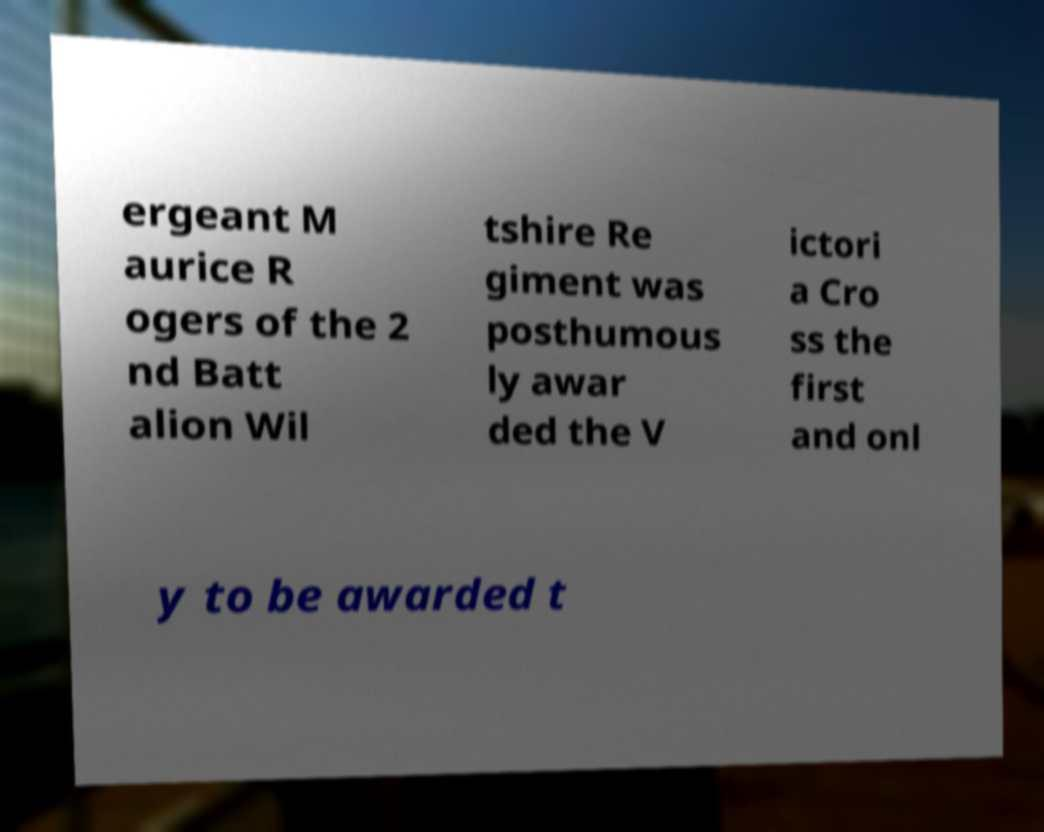Can you accurately transcribe the text from the provided image for me? ergeant M aurice R ogers of the 2 nd Batt alion Wil tshire Re giment was posthumous ly awar ded the V ictori a Cro ss the first and onl y to be awarded t 